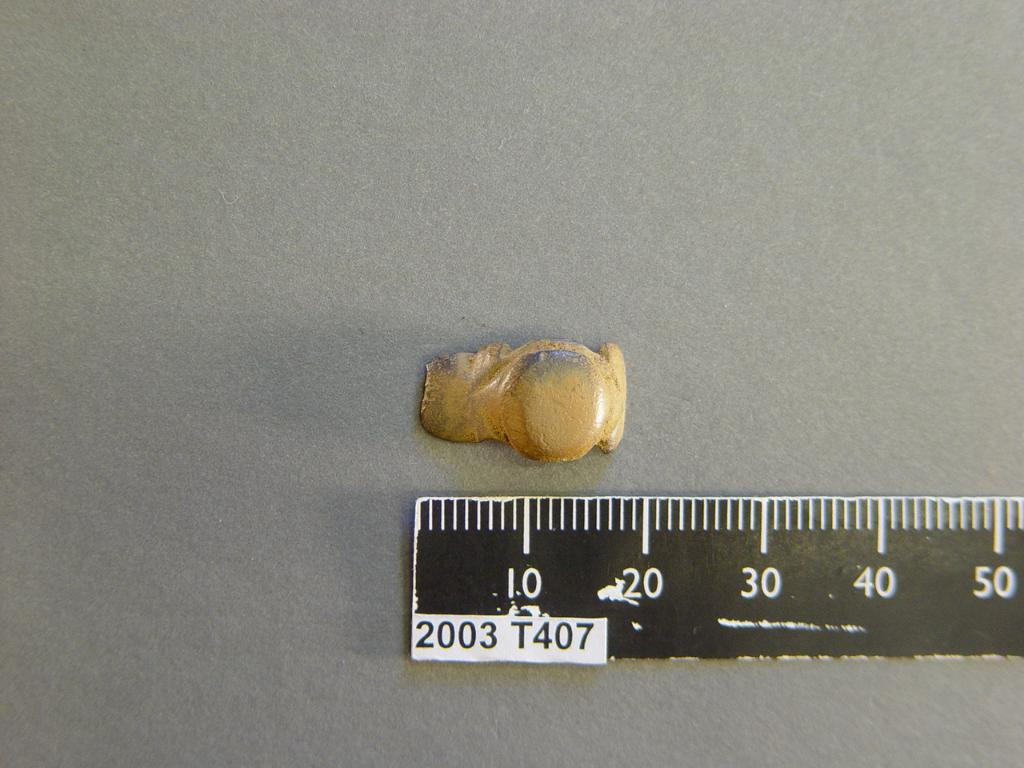<image>
Offer a succinct explanation of the picture presented. A ruler lies next to some sort of object measuring it as almost 20mm long. 